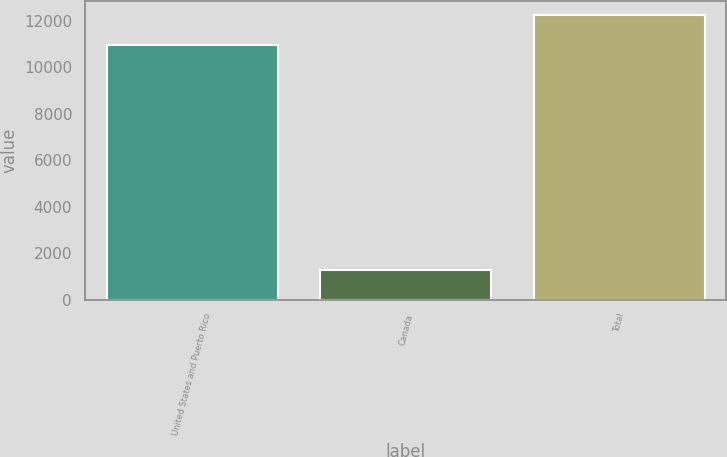Convert chart. <chart><loc_0><loc_0><loc_500><loc_500><bar_chart><fcel>United States and Puerto Rico<fcel>Canada<fcel>Total<nl><fcel>10948<fcel>1294<fcel>12242<nl></chart> 